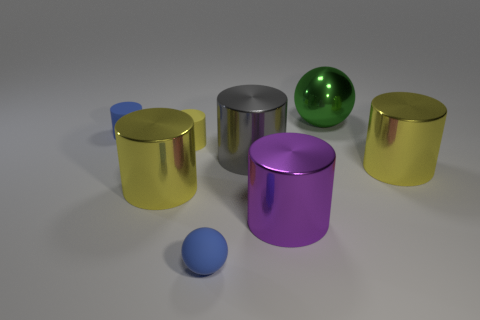Subtract all yellow cylinders. How many were subtracted if there are1yellow cylinders left? 2 Subtract all brown balls. How many yellow cylinders are left? 3 Subtract all blue cylinders. How many cylinders are left? 5 Subtract all large yellow cylinders. How many cylinders are left? 4 Subtract all gray cylinders. Subtract all blue balls. How many cylinders are left? 5 Add 2 matte things. How many objects exist? 10 Subtract all balls. How many objects are left? 6 Add 7 yellow rubber cylinders. How many yellow rubber cylinders are left? 8 Add 3 large gray rubber things. How many large gray rubber things exist? 3 Subtract 0 brown cylinders. How many objects are left? 8 